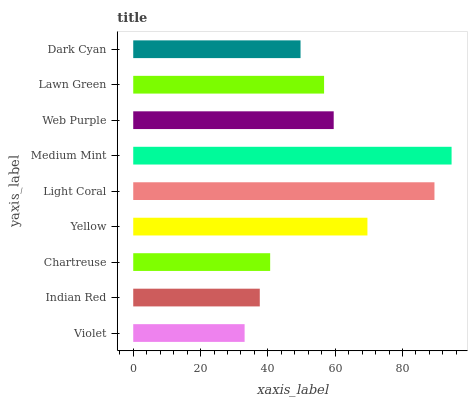Is Violet the minimum?
Answer yes or no. Yes. Is Medium Mint the maximum?
Answer yes or no. Yes. Is Indian Red the minimum?
Answer yes or no. No. Is Indian Red the maximum?
Answer yes or no. No. Is Indian Red greater than Violet?
Answer yes or no. Yes. Is Violet less than Indian Red?
Answer yes or no. Yes. Is Violet greater than Indian Red?
Answer yes or no. No. Is Indian Red less than Violet?
Answer yes or no. No. Is Lawn Green the high median?
Answer yes or no. Yes. Is Lawn Green the low median?
Answer yes or no. Yes. Is Yellow the high median?
Answer yes or no. No. Is Dark Cyan the low median?
Answer yes or no. No. 